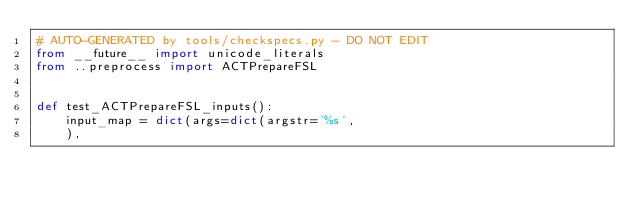<code> <loc_0><loc_0><loc_500><loc_500><_Python_># AUTO-GENERATED by tools/checkspecs.py - DO NOT EDIT
from __future__ import unicode_literals
from ..preprocess import ACTPrepareFSL


def test_ACTPrepareFSL_inputs():
    input_map = dict(args=dict(argstr='%s',
    ),</code> 